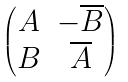<formula> <loc_0><loc_0><loc_500><loc_500>\begin{pmatrix} A & - \overline { B } \\ B & \overline { A } \end{pmatrix}</formula> 